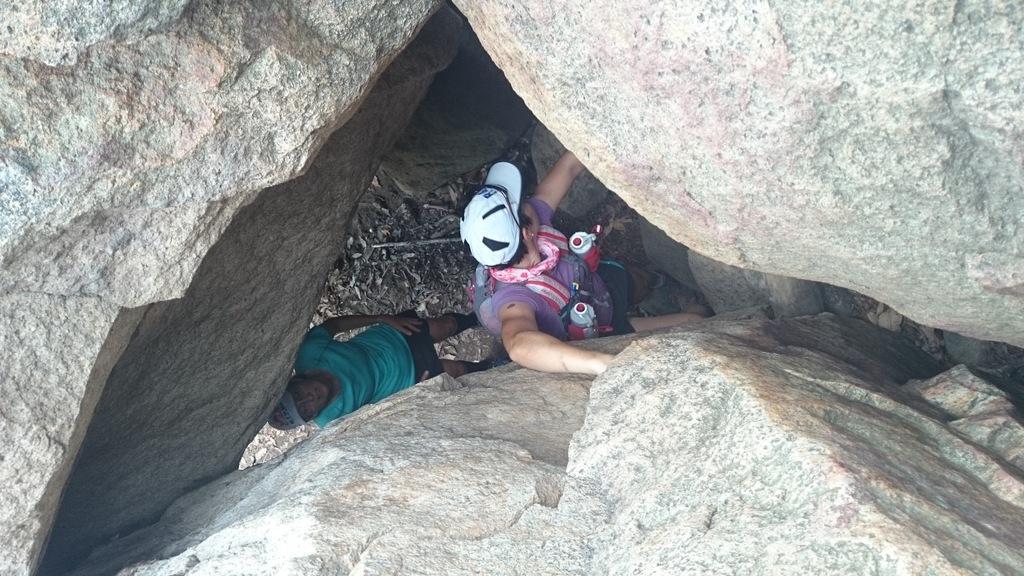How would you summarize this image in a sentence or two? In this picture we can see two persons standing, they wore caps, we can see rocks here, at the bottom there are some sticks. 